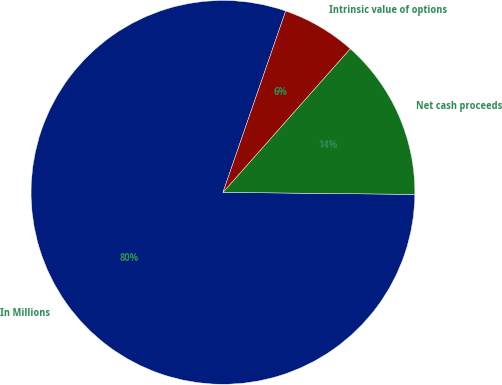<chart> <loc_0><loc_0><loc_500><loc_500><pie_chart><fcel>In Millions<fcel>Net cash proceeds<fcel>Intrinsic value of options<nl><fcel>80.13%<fcel>13.63%<fcel>6.24%<nl></chart> 